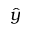Convert formula to latex. <formula><loc_0><loc_0><loc_500><loc_500>\hat { y }</formula> 